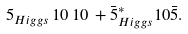<formula> <loc_0><loc_0><loc_500><loc_500>5 _ { H i g g s } \, 1 0 \, 1 0 \, + \bar { 5 } _ { H i g g s } ^ { * } 1 0 \bar { 5 } .</formula> 